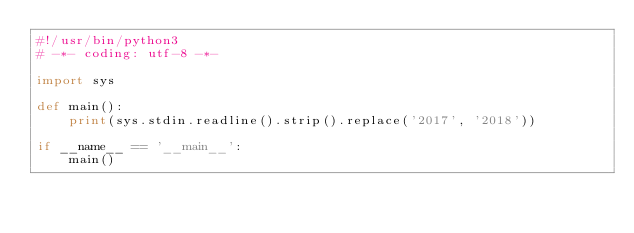<code> <loc_0><loc_0><loc_500><loc_500><_Python_>#!/usr/bin/python3
# -*- coding: utf-8 -*-

import sys

def main():
    print(sys.stdin.readline().strip().replace('2017', '2018'))

if __name__ == '__main__':
    main()
</code> 